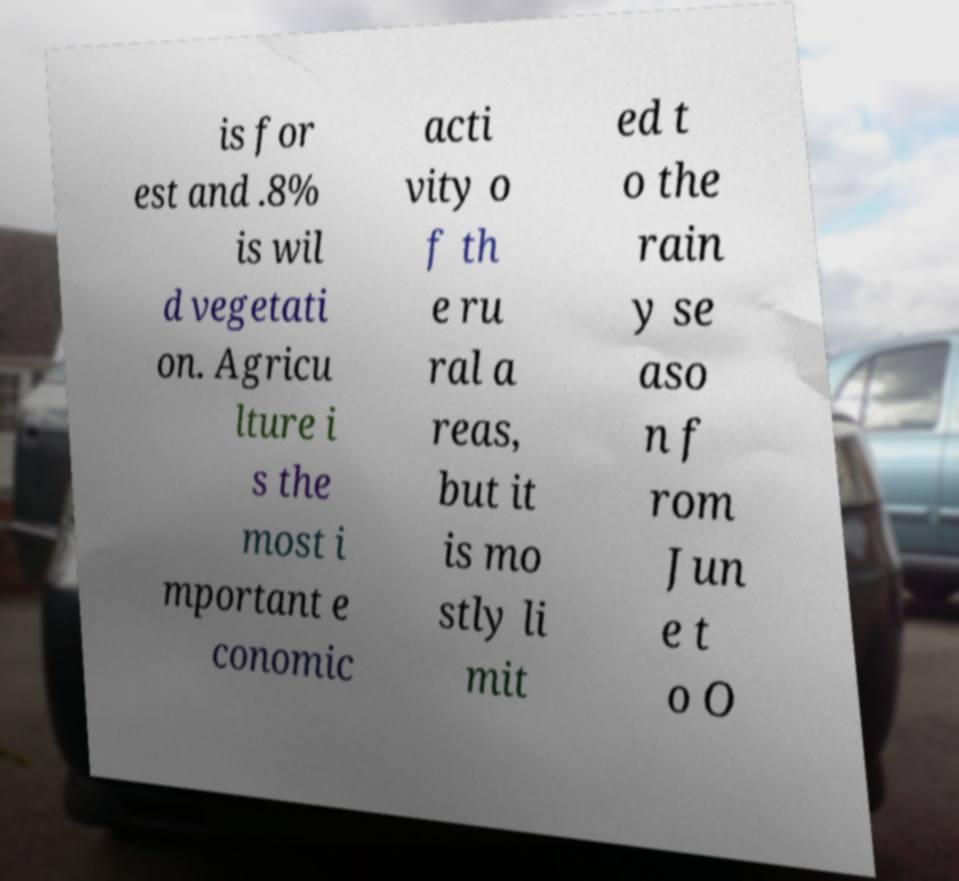Could you extract and type out the text from this image? is for est and .8% is wil d vegetati on. Agricu lture i s the most i mportant e conomic acti vity o f th e ru ral a reas, but it is mo stly li mit ed t o the rain y se aso n f rom Jun e t o O 